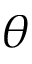Convert formula to latex. <formula><loc_0><loc_0><loc_500><loc_500>\theta</formula> 